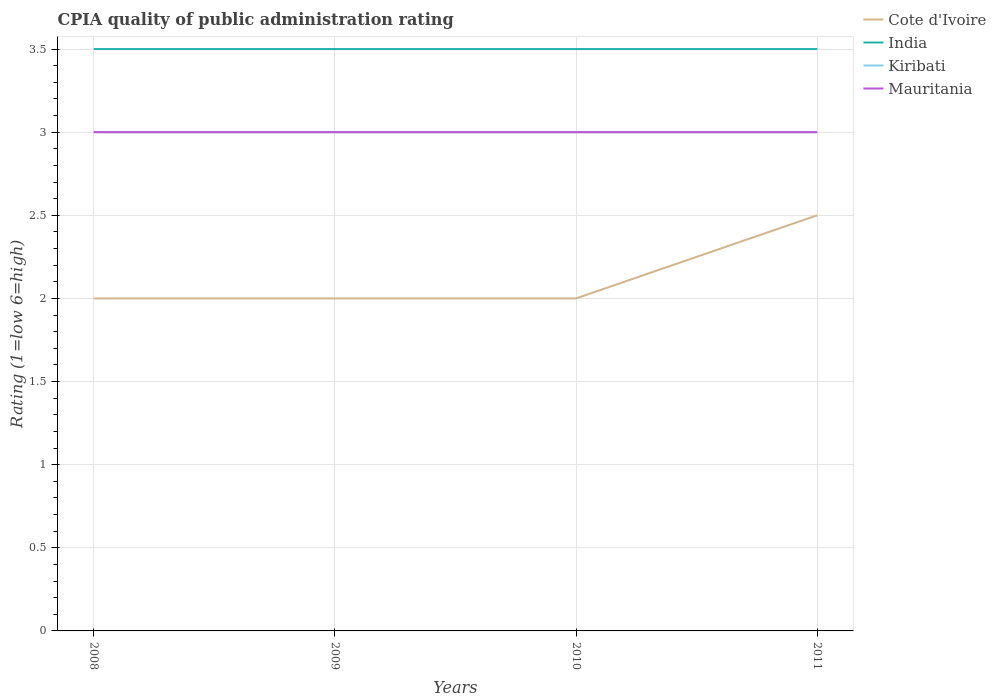Does the line corresponding to India intersect with the line corresponding to Mauritania?
Provide a succinct answer. No. In which year was the CPIA rating in India maximum?
Provide a succinct answer. 2008. What is the total CPIA rating in Kiribati in the graph?
Provide a short and direct response. 0. Is the CPIA rating in Cote d'Ivoire strictly greater than the CPIA rating in India over the years?
Keep it short and to the point. Yes. How many lines are there?
Your answer should be compact. 4. How many years are there in the graph?
Offer a terse response. 4. Where does the legend appear in the graph?
Provide a short and direct response. Top right. What is the title of the graph?
Keep it short and to the point. CPIA quality of public administration rating. What is the label or title of the X-axis?
Make the answer very short. Years. What is the label or title of the Y-axis?
Ensure brevity in your answer.  Rating (1=low 6=high). What is the Rating (1=low 6=high) of India in 2008?
Offer a terse response. 3.5. What is the Rating (1=low 6=high) in Kiribati in 2008?
Offer a very short reply. 3. What is the Rating (1=low 6=high) of Cote d'Ivoire in 2009?
Offer a terse response. 2. What is the Rating (1=low 6=high) in Kiribati in 2009?
Offer a very short reply. 3. What is the Rating (1=low 6=high) in Mauritania in 2009?
Your answer should be compact. 3. What is the Rating (1=low 6=high) in Cote d'Ivoire in 2010?
Keep it short and to the point. 2. What is the Rating (1=low 6=high) of Mauritania in 2010?
Your answer should be very brief. 3. What is the Rating (1=low 6=high) of Cote d'Ivoire in 2011?
Your answer should be compact. 2.5. What is the Rating (1=low 6=high) of Kiribati in 2011?
Provide a succinct answer. 3. What is the Rating (1=low 6=high) of Mauritania in 2011?
Make the answer very short. 3. Across all years, what is the maximum Rating (1=low 6=high) of Cote d'Ivoire?
Provide a short and direct response. 2.5. Across all years, what is the maximum Rating (1=low 6=high) of India?
Your answer should be very brief. 3.5. Across all years, what is the maximum Rating (1=low 6=high) of Kiribati?
Offer a very short reply. 3. Across all years, what is the maximum Rating (1=low 6=high) of Mauritania?
Ensure brevity in your answer.  3. Across all years, what is the minimum Rating (1=low 6=high) of India?
Your answer should be compact. 3.5. What is the total Rating (1=low 6=high) of Cote d'Ivoire in the graph?
Provide a short and direct response. 8.5. What is the total Rating (1=low 6=high) of India in the graph?
Offer a terse response. 14. What is the total Rating (1=low 6=high) of Kiribati in the graph?
Your response must be concise. 12. What is the difference between the Rating (1=low 6=high) in Kiribati in 2008 and that in 2009?
Keep it short and to the point. 0. What is the difference between the Rating (1=low 6=high) of Kiribati in 2008 and that in 2010?
Your answer should be very brief. 0. What is the difference between the Rating (1=low 6=high) of Mauritania in 2008 and that in 2010?
Your response must be concise. 0. What is the difference between the Rating (1=low 6=high) in Kiribati in 2008 and that in 2011?
Ensure brevity in your answer.  0. What is the difference between the Rating (1=low 6=high) of Kiribati in 2009 and that in 2010?
Ensure brevity in your answer.  0. What is the difference between the Rating (1=low 6=high) of Mauritania in 2009 and that in 2010?
Give a very brief answer. 0. What is the difference between the Rating (1=low 6=high) of India in 2009 and that in 2011?
Provide a short and direct response. 0. What is the difference between the Rating (1=low 6=high) of Kiribati in 2009 and that in 2011?
Your answer should be very brief. 0. What is the difference between the Rating (1=low 6=high) of Mauritania in 2009 and that in 2011?
Offer a very short reply. 0. What is the difference between the Rating (1=low 6=high) of Kiribati in 2010 and that in 2011?
Keep it short and to the point. 0. What is the difference between the Rating (1=low 6=high) of Cote d'Ivoire in 2008 and the Rating (1=low 6=high) of India in 2009?
Make the answer very short. -1.5. What is the difference between the Rating (1=low 6=high) in India in 2008 and the Rating (1=low 6=high) in Kiribati in 2009?
Offer a terse response. 0.5. What is the difference between the Rating (1=low 6=high) in Kiribati in 2008 and the Rating (1=low 6=high) in Mauritania in 2009?
Your answer should be very brief. 0. What is the difference between the Rating (1=low 6=high) of Cote d'Ivoire in 2008 and the Rating (1=low 6=high) of India in 2010?
Your answer should be very brief. -1.5. What is the difference between the Rating (1=low 6=high) in India in 2008 and the Rating (1=low 6=high) in Kiribati in 2010?
Give a very brief answer. 0.5. What is the difference between the Rating (1=low 6=high) of India in 2008 and the Rating (1=low 6=high) of Mauritania in 2010?
Make the answer very short. 0.5. What is the difference between the Rating (1=low 6=high) of Cote d'Ivoire in 2008 and the Rating (1=low 6=high) of India in 2011?
Provide a succinct answer. -1.5. What is the difference between the Rating (1=low 6=high) in India in 2008 and the Rating (1=low 6=high) in Kiribati in 2011?
Make the answer very short. 0.5. What is the difference between the Rating (1=low 6=high) of India in 2008 and the Rating (1=low 6=high) of Mauritania in 2011?
Ensure brevity in your answer.  0.5. What is the difference between the Rating (1=low 6=high) of Cote d'Ivoire in 2009 and the Rating (1=low 6=high) of India in 2010?
Your response must be concise. -1.5. What is the difference between the Rating (1=low 6=high) in Cote d'Ivoire in 2009 and the Rating (1=low 6=high) in Kiribati in 2010?
Your answer should be compact. -1. What is the difference between the Rating (1=low 6=high) of India in 2009 and the Rating (1=low 6=high) of Kiribati in 2010?
Ensure brevity in your answer.  0.5. What is the difference between the Rating (1=low 6=high) of Kiribati in 2009 and the Rating (1=low 6=high) of Mauritania in 2010?
Offer a terse response. 0. What is the difference between the Rating (1=low 6=high) in Cote d'Ivoire in 2009 and the Rating (1=low 6=high) in Mauritania in 2011?
Keep it short and to the point. -1. What is the difference between the Rating (1=low 6=high) of India in 2009 and the Rating (1=low 6=high) of Kiribati in 2011?
Give a very brief answer. 0.5. What is the difference between the Rating (1=low 6=high) of Kiribati in 2009 and the Rating (1=low 6=high) of Mauritania in 2011?
Offer a very short reply. 0. What is the difference between the Rating (1=low 6=high) in Cote d'Ivoire in 2010 and the Rating (1=low 6=high) in India in 2011?
Your answer should be compact. -1.5. What is the difference between the Rating (1=low 6=high) in Cote d'Ivoire in 2010 and the Rating (1=low 6=high) in Kiribati in 2011?
Offer a very short reply. -1. What is the difference between the Rating (1=low 6=high) of Cote d'Ivoire in 2010 and the Rating (1=low 6=high) of Mauritania in 2011?
Provide a short and direct response. -1. What is the difference between the Rating (1=low 6=high) of India in 2010 and the Rating (1=low 6=high) of Kiribati in 2011?
Make the answer very short. 0.5. What is the difference between the Rating (1=low 6=high) in India in 2010 and the Rating (1=low 6=high) in Mauritania in 2011?
Your answer should be compact. 0.5. What is the difference between the Rating (1=low 6=high) in Kiribati in 2010 and the Rating (1=low 6=high) in Mauritania in 2011?
Give a very brief answer. 0. What is the average Rating (1=low 6=high) of Cote d'Ivoire per year?
Ensure brevity in your answer.  2.12. What is the average Rating (1=low 6=high) in Kiribati per year?
Your answer should be very brief. 3. What is the average Rating (1=low 6=high) in Mauritania per year?
Keep it short and to the point. 3. In the year 2008, what is the difference between the Rating (1=low 6=high) of Cote d'Ivoire and Rating (1=low 6=high) of Mauritania?
Provide a succinct answer. -1. In the year 2008, what is the difference between the Rating (1=low 6=high) of Kiribati and Rating (1=low 6=high) of Mauritania?
Your answer should be very brief. 0. In the year 2009, what is the difference between the Rating (1=low 6=high) in Cote d'Ivoire and Rating (1=low 6=high) in India?
Make the answer very short. -1.5. In the year 2010, what is the difference between the Rating (1=low 6=high) of Cote d'Ivoire and Rating (1=low 6=high) of India?
Offer a very short reply. -1.5. In the year 2010, what is the difference between the Rating (1=low 6=high) of Cote d'Ivoire and Rating (1=low 6=high) of Kiribati?
Your answer should be compact. -1. In the year 2010, what is the difference between the Rating (1=low 6=high) in Cote d'Ivoire and Rating (1=low 6=high) in Mauritania?
Make the answer very short. -1. In the year 2010, what is the difference between the Rating (1=low 6=high) in India and Rating (1=low 6=high) in Kiribati?
Your response must be concise. 0.5. In the year 2010, what is the difference between the Rating (1=low 6=high) in Kiribati and Rating (1=low 6=high) in Mauritania?
Ensure brevity in your answer.  0. In the year 2011, what is the difference between the Rating (1=low 6=high) of Cote d'Ivoire and Rating (1=low 6=high) of India?
Provide a short and direct response. -1. In the year 2011, what is the difference between the Rating (1=low 6=high) of Cote d'Ivoire and Rating (1=low 6=high) of Kiribati?
Your answer should be compact. -0.5. In the year 2011, what is the difference between the Rating (1=low 6=high) in India and Rating (1=low 6=high) in Kiribati?
Your answer should be very brief. 0.5. In the year 2011, what is the difference between the Rating (1=low 6=high) in India and Rating (1=low 6=high) in Mauritania?
Offer a very short reply. 0.5. In the year 2011, what is the difference between the Rating (1=low 6=high) in Kiribati and Rating (1=low 6=high) in Mauritania?
Provide a succinct answer. 0. What is the ratio of the Rating (1=low 6=high) of India in 2008 to that in 2009?
Provide a short and direct response. 1. What is the ratio of the Rating (1=low 6=high) in Kiribati in 2008 to that in 2009?
Make the answer very short. 1. What is the ratio of the Rating (1=low 6=high) in Cote d'Ivoire in 2008 to that in 2010?
Keep it short and to the point. 1. What is the ratio of the Rating (1=low 6=high) of India in 2008 to that in 2010?
Provide a succinct answer. 1. What is the ratio of the Rating (1=low 6=high) in Kiribati in 2008 to that in 2010?
Offer a terse response. 1. What is the ratio of the Rating (1=low 6=high) in Cote d'Ivoire in 2008 to that in 2011?
Give a very brief answer. 0.8. What is the ratio of the Rating (1=low 6=high) of India in 2008 to that in 2011?
Offer a terse response. 1. What is the ratio of the Rating (1=low 6=high) in Kiribati in 2008 to that in 2011?
Your response must be concise. 1. What is the ratio of the Rating (1=low 6=high) in Mauritania in 2008 to that in 2011?
Offer a terse response. 1. What is the ratio of the Rating (1=low 6=high) in Cote d'Ivoire in 2009 to that in 2010?
Provide a short and direct response. 1. What is the ratio of the Rating (1=low 6=high) in Mauritania in 2009 to that in 2010?
Offer a very short reply. 1. What is the ratio of the Rating (1=low 6=high) in India in 2009 to that in 2011?
Offer a very short reply. 1. What is the ratio of the Rating (1=low 6=high) in India in 2010 to that in 2011?
Your answer should be compact. 1. What is the ratio of the Rating (1=low 6=high) in Mauritania in 2010 to that in 2011?
Your response must be concise. 1. What is the difference between the highest and the second highest Rating (1=low 6=high) of Kiribati?
Your answer should be compact. 0. What is the difference between the highest and the lowest Rating (1=low 6=high) of Cote d'Ivoire?
Your answer should be compact. 0.5. What is the difference between the highest and the lowest Rating (1=low 6=high) of Kiribati?
Provide a short and direct response. 0. 